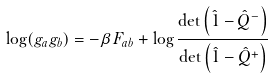Convert formula to latex. <formula><loc_0><loc_0><loc_500><loc_500>\log ( g _ { a } g _ { b } ) = - \beta F _ { a b } + \log \frac { \det \left ( \hat { 1 } - \hat { Q } ^ { - } \right ) } { \det \left ( \hat { 1 } - \hat { Q } ^ { + } \right ) }</formula> 